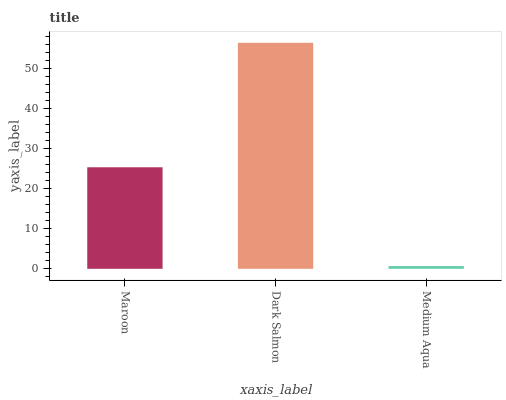Is Medium Aqua the minimum?
Answer yes or no. Yes. Is Dark Salmon the maximum?
Answer yes or no. Yes. Is Dark Salmon the minimum?
Answer yes or no. No. Is Medium Aqua the maximum?
Answer yes or no. No. Is Dark Salmon greater than Medium Aqua?
Answer yes or no. Yes. Is Medium Aqua less than Dark Salmon?
Answer yes or no. Yes. Is Medium Aqua greater than Dark Salmon?
Answer yes or no. No. Is Dark Salmon less than Medium Aqua?
Answer yes or no. No. Is Maroon the high median?
Answer yes or no. Yes. Is Maroon the low median?
Answer yes or no. Yes. Is Medium Aqua the high median?
Answer yes or no. No. Is Medium Aqua the low median?
Answer yes or no. No. 